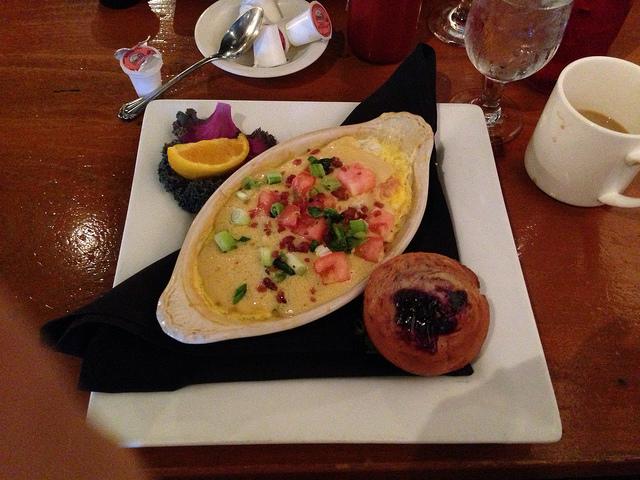What beverage is in the white mug?
Answer briefly. Coffee. What type of jam is on the bread?
Concise answer only. Grape. What is in the glasses?
Keep it brief. Water. Does the coffee have cream?
Give a very brief answer. Yes. Does this person have fruit to eat?
Quick response, please. Yes. Is the liquid in the glass water?
Give a very brief answer. Yes. 